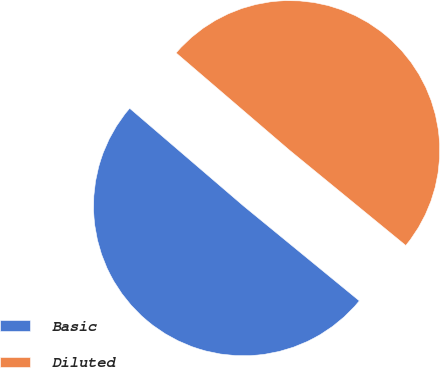<chart> <loc_0><loc_0><loc_500><loc_500><pie_chart><fcel>Basic<fcel>Diluted<nl><fcel>50.36%<fcel>49.64%<nl></chart> 